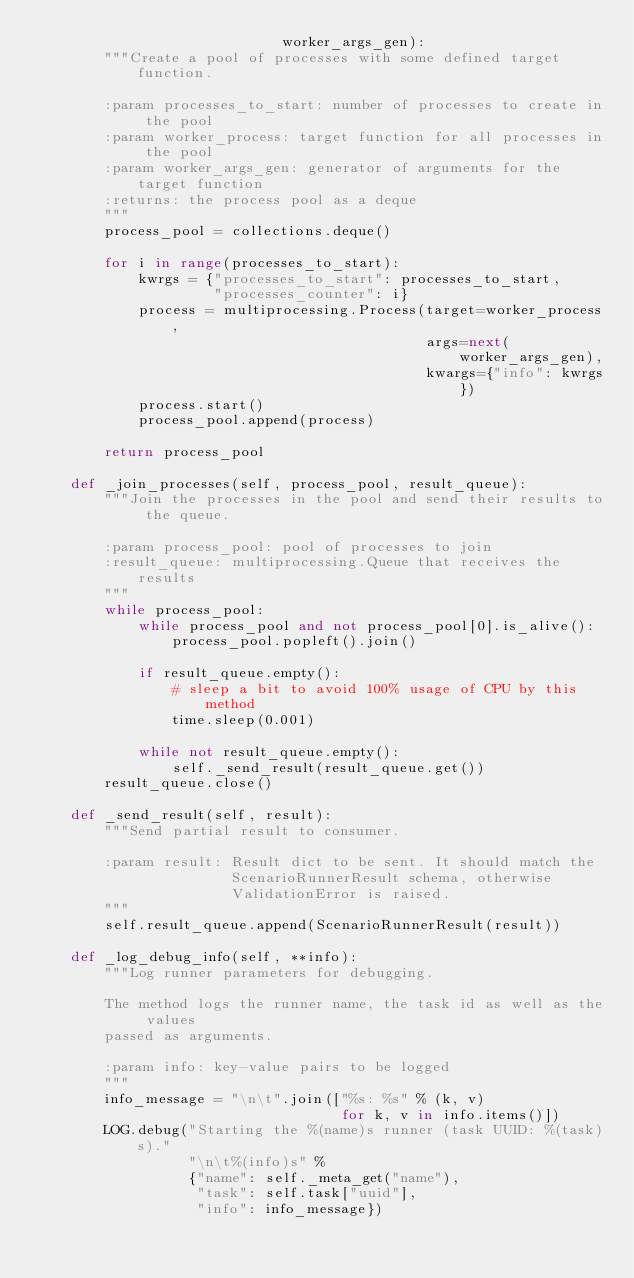<code> <loc_0><loc_0><loc_500><loc_500><_Python_>                             worker_args_gen):
        """Create a pool of processes with some defined target function.

        :param processes_to_start: number of processes to create in the pool
        :param worker_process: target function for all processes in the pool
        :param worker_args_gen: generator of arguments for the target function
        :returns: the process pool as a deque
        """
        process_pool = collections.deque()

        for i in range(processes_to_start):
            kwrgs = {"processes_to_start": processes_to_start,
                     "processes_counter": i}
            process = multiprocessing.Process(target=worker_process,
                                              args=next(worker_args_gen),
                                              kwargs={"info": kwrgs})
            process.start()
            process_pool.append(process)

        return process_pool

    def _join_processes(self, process_pool, result_queue):
        """Join the processes in the pool and send their results to the queue.

        :param process_pool: pool of processes to join
        :result_queue: multiprocessing.Queue that receives the results
        """
        while process_pool:
            while process_pool and not process_pool[0].is_alive():
                process_pool.popleft().join()

            if result_queue.empty():
                # sleep a bit to avoid 100% usage of CPU by this method
                time.sleep(0.001)

            while not result_queue.empty():
                self._send_result(result_queue.get())
        result_queue.close()

    def _send_result(self, result):
        """Send partial result to consumer.

        :param result: Result dict to be sent. It should match the
                       ScenarioRunnerResult schema, otherwise
                       ValidationError is raised.
        """
        self.result_queue.append(ScenarioRunnerResult(result))

    def _log_debug_info(self, **info):
        """Log runner parameters for debugging.

        The method logs the runner name, the task id as well as the values
        passed as arguments.

        :param info: key-value pairs to be logged
        """
        info_message = "\n\t".join(["%s: %s" % (k, v)
                                    for k, v in info.items()])
        LOG.debug("Starting the %(name)s runner (task UUID: %(task)s)."
                  "\n\t%(info)s" %
                  {"name": self._meta_get("name"),
                   "task": self.task["uuid"],
                   "info": info_message})
</code> 